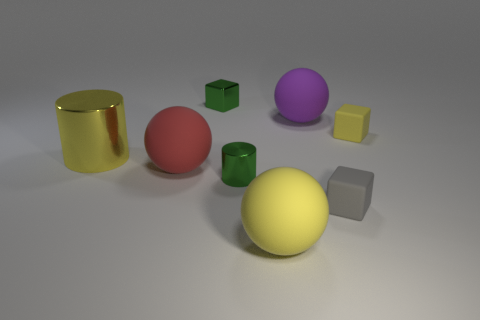What size is the gray thing that is the same material as the large red thing?
Make the answer very short. Small. There is another tiny block that is the same material as the tiny yellow cube; what color is it?
Offer a terse response. Gray. Are there any red matte things that have the same size as the yellow cylinder?
Give a very brief answer. Yes. What is the material of the large yellow object that is the same shape as the big purple object?
Offer a very short reply. Rubber. The green metal object that is the same size as the green cube is what shape?
Your answer should be compact. Cylinder. Are there any other tiny matte things of the same shape as the gray rubber thing?
Give a very brief answer. Yes. There is a large yellow object that is to the left of the red thing behind the gray cube; what is its shape?
Offer a very short reply. Cylinder. What shape is the small yellow thing?
Provide a succinct answer. Cube. There is a cube that is left of the large matte thing in front of the metallic cylinder to the right of the small green block; what is its material?
Offer a very short reply. Metal. How many other objects are the same material as the tiny yellow object?
Provide a short and direct response. 4. 